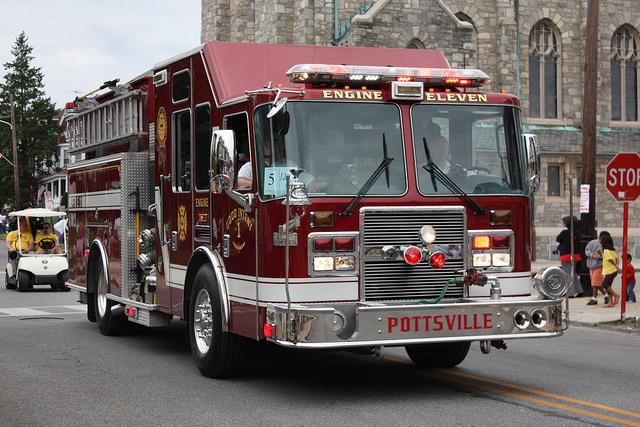Which side of the road is the fire truck driving on? right 